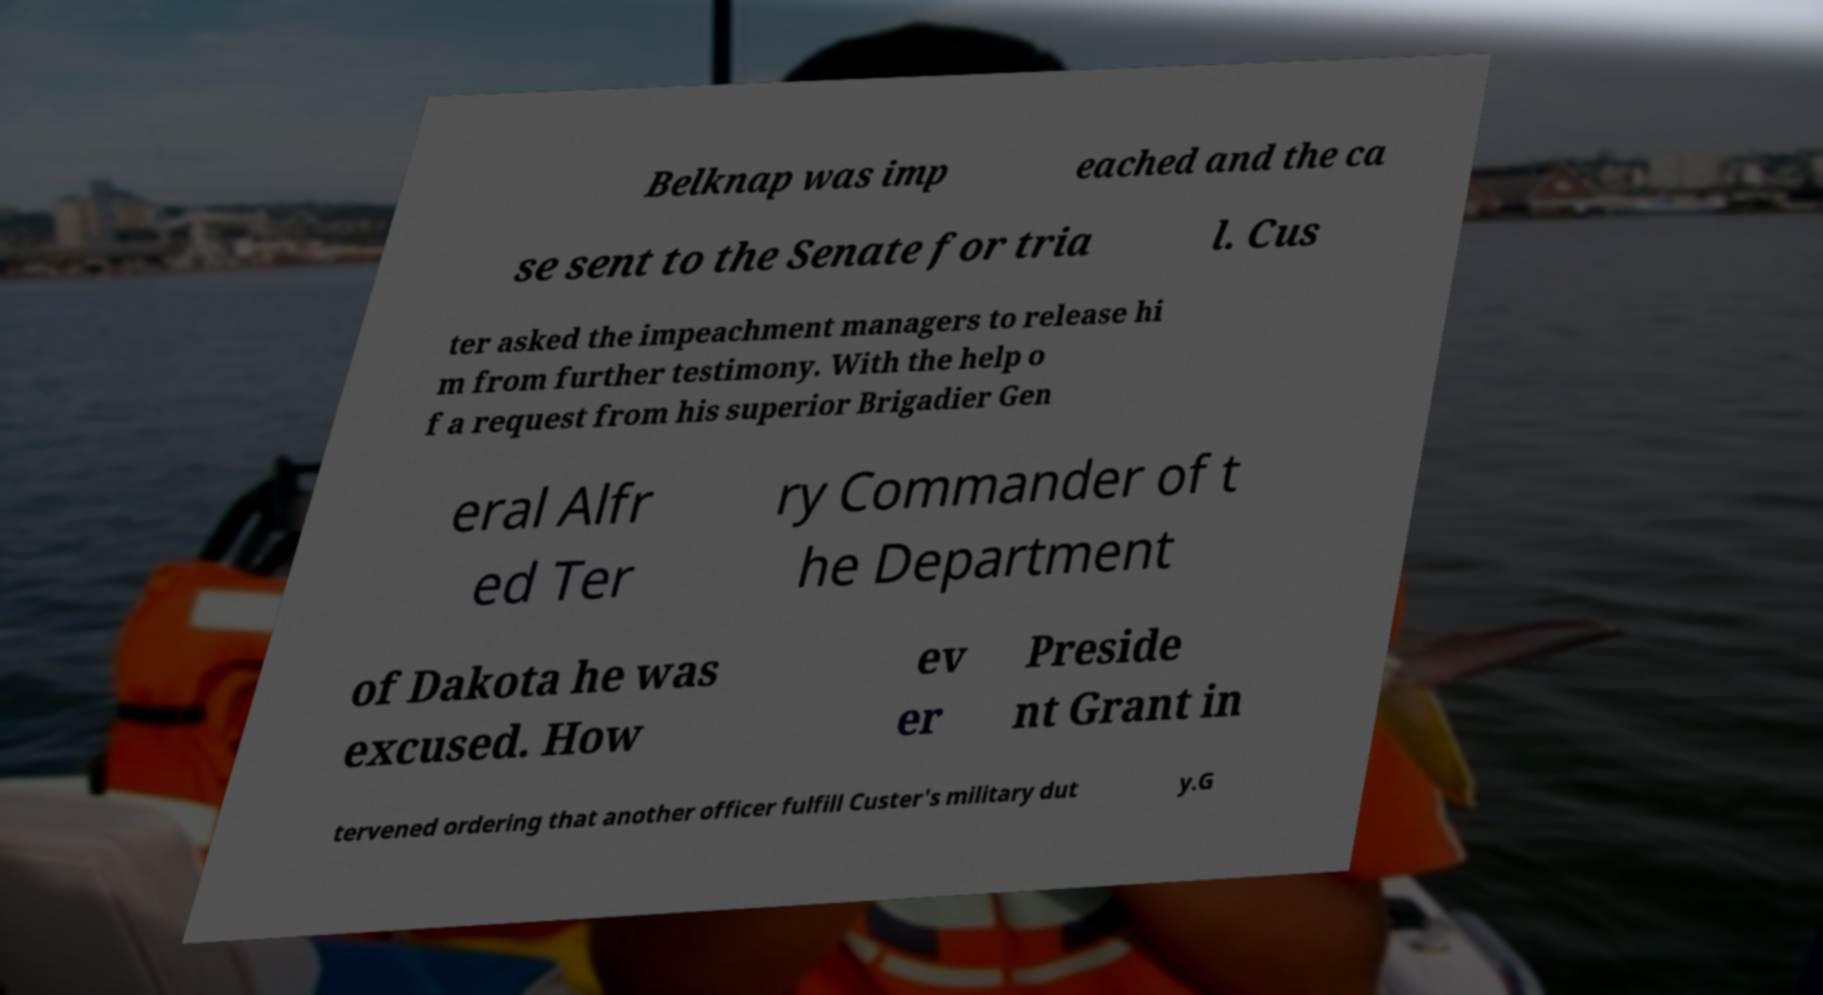Can you read and provide the text displayed in the image?This photo seems to have some interesting text. Can you extract and type it out for me? Belknap was imp eached and the ca se sent to the Senate for tria l. Cus ter asked the impeachment managers to release hi m from further testimony. With the help o f a request from his superior Brigadier Gen eral Alfr ed Ter ry Commander of t he Department of Dakota he was excused. How ev er Preside nt Grant in tervened ordering that another officer fulfill Custer's military dut y.G 